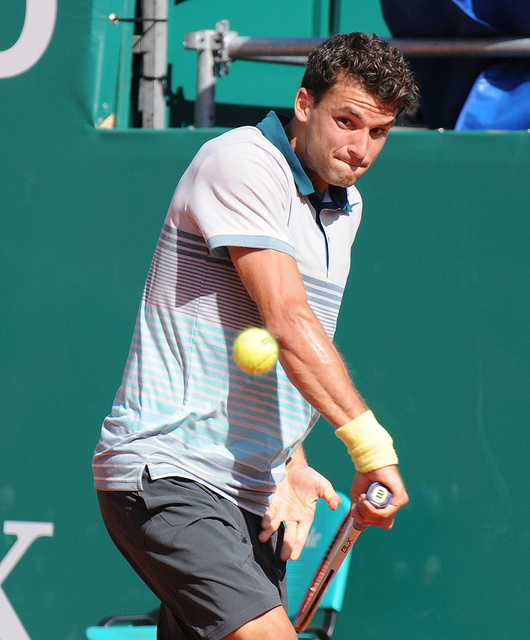Describe the objects in this image and their specific colors. I can see people in teal, white, black, gray, and darkgray tones, tennis racket in teal, brown, maroon, darkgray, and gray tones, and sports ball in teal, lightyellow, khaki, and orange tones in this image. 